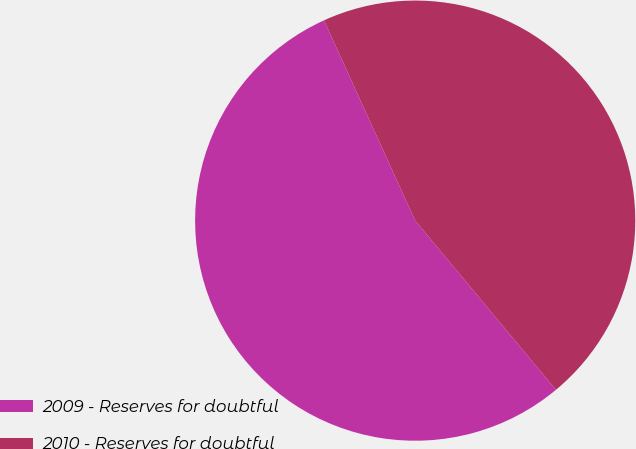Convert chart. <chart><loc_0><loc_0><loc_500><loc_500><pie_chart><fcel>2009 - Reserves for doubtful<fcel>2010 - Reserves for doubtful<nl><fcel>54.24%<fcel>45.76%<nl></chart> 